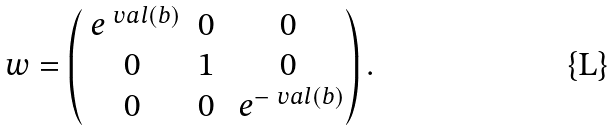<formula> <loc_0><loc_0><loc_500><loc_500>\ w = \begin{pmatrix} \ e ^ { \ v a l ( b ) } & 0 & 0 \\ 0 & 1 & 0 \\ 0 & 0 & \ e ^ { - \ v a l ( b ) } \end{pmatrix} .</formula> 